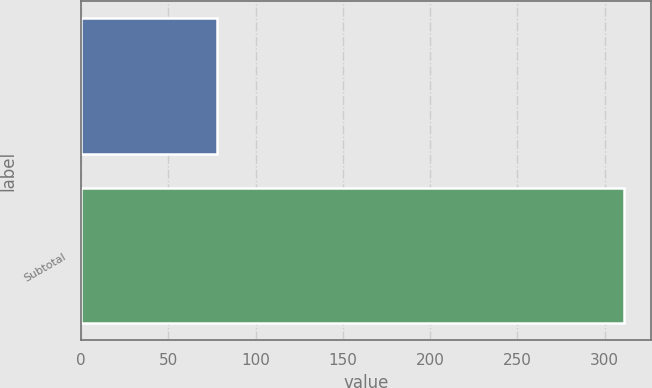Convert chart to OTSL. <chart><loc_0><loc_0><loc_500><loc_500><bar_chart><ecel><fcel>Subtotal<nl><fcel>77.9<fcel>311<nl></chart> 